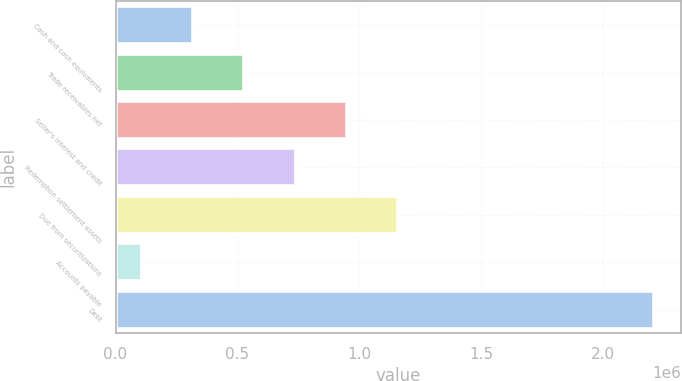Convert chart. <chart><loc_0><loc_0><loc_500><loc_500><bar_chart><fcel>Cash and cash equivalents<fcel>Trade receivables net<fcel>Seller's interest and credit<fcel>Redemption settlement assets<fcel>Due from securitizations<fcel>Accounts payable<fcel>Debt<nl><fcel>318191<fcel>528013<fcel>947656<fcel>737834<fcel>1.15748e+06<fcel>108369<fcel>2.20659e+06<nl></chart> 